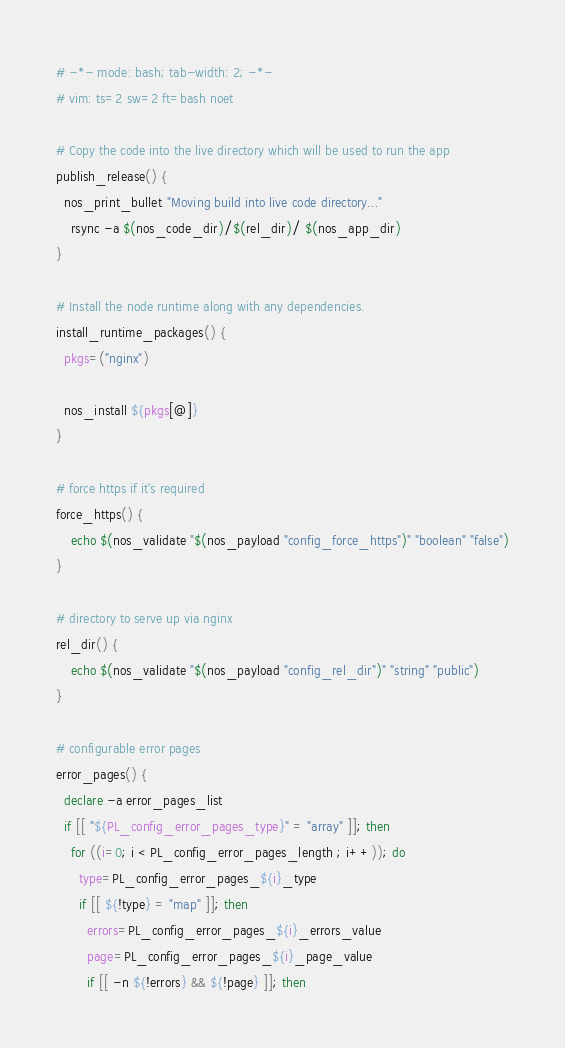Convert code to text. <code><loc_0><loc_0><loc_500><loc_500><_Bash_># -*- mode: bash; tab-width: 2; -*-
# vim: ts=2 sw=2 ft=bash noet

# Copy the code into the live directory which will be used to run the app
publish_release() {
  nos_print_bullet "Moving build into live code directory..."
	rsync -a $(nos_code_dir)/$(rel_dir)/ $(nos_app_dir)
}

# Install the node runtime along with any dependencies.
install_runtime_packages() {
  pkgs=("nginx")

  nos_install ${pkgs[@]}
}

# force https if it's required
force_https() {
	echo $(nos_validate "$(nos_payload "config_force_https")" "boolean" "false")
}

# directory to serve up via nginx
rel_dir() {
	echo $(nos_validate "$(nos_payload "config_rel_dir")" "string" "public")
}

# configurable error pages
error_pages() {
  declare -a error_pages_list
  if [[ "${PL_config_error_pages_type}" = "array" ]]; then
    for ((i=0; i < PL_config_error_pages_length ; i++)); do
      type=PL_config_error_pages_${i}_type
      if [[ ${!type} = "map" ]]; then
        errors=PL_config_error_pages_${i}_errors_value
        page=PL_config_error_pages_${i}_page_value
        if [[ -n ${!errors} && ${!page} ]]; then</code> 